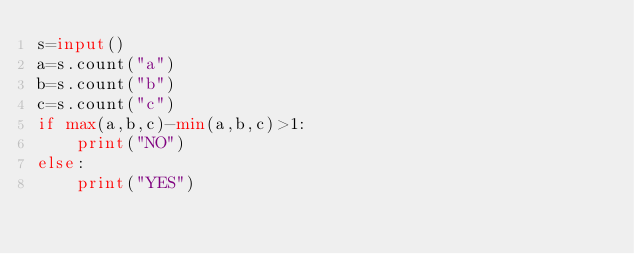<code> <loc_0><loc_0><loc_500><loc_500><_Python_>s=input()
a=s.count("a")
b=s.count("b")
c=s.count("c")
if max(a,b,c)-min(a,b,c)>1:
	print("NO")
else:
	print("YES")</code> 